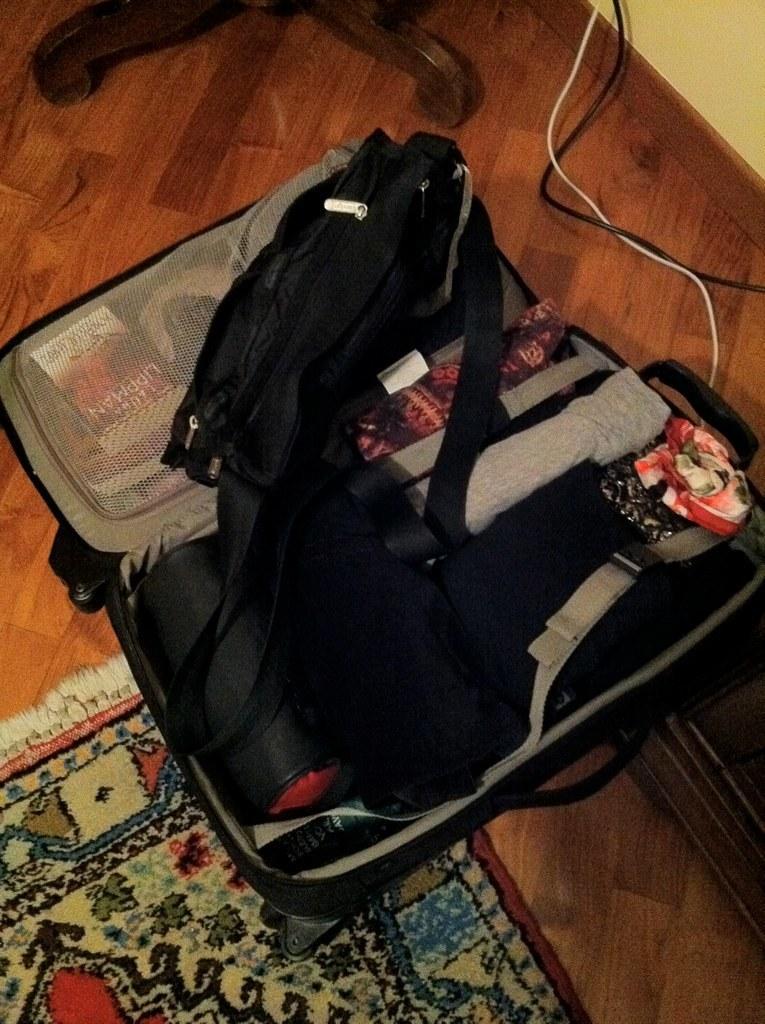Can you describe this image briefly? In this picture we can see a briefcase on the floor. This is carpet. And these are the cables. Here there is a wall and this is the floor. 